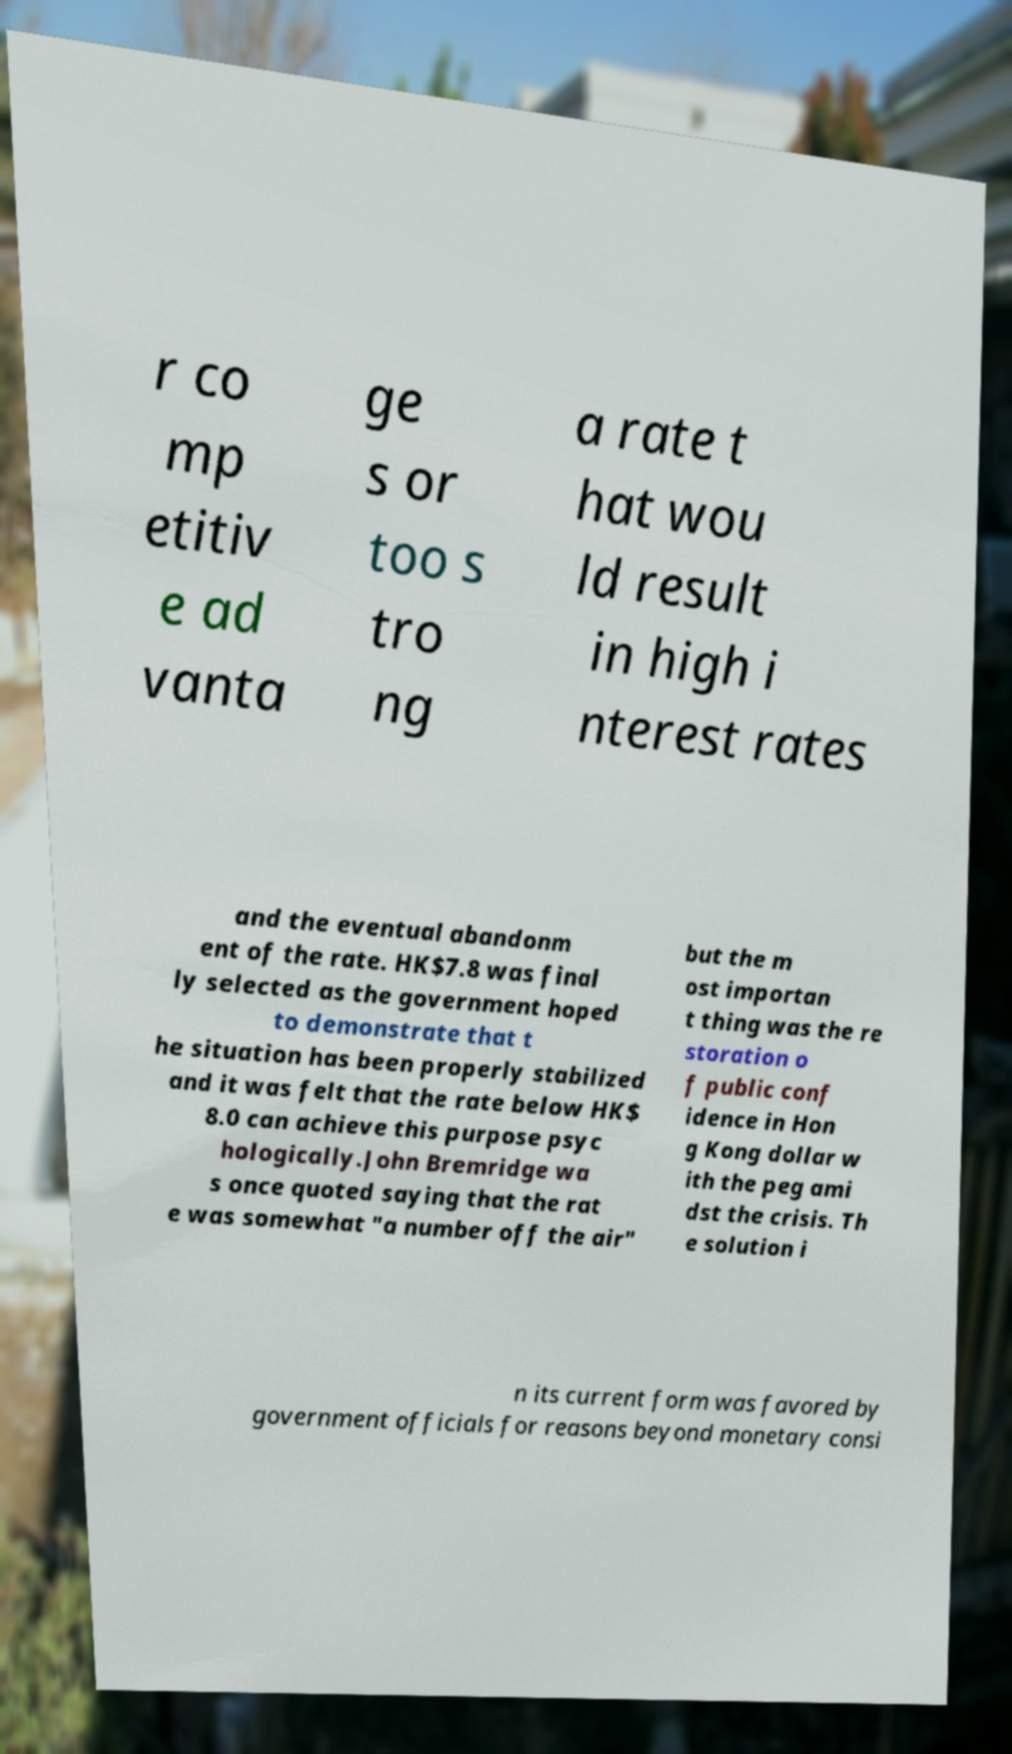There's text embedded in this image that I need extracted. Can you transcribe it verbatim? r co mp etitiv e ad vanta ge s or too s tro ng a rate t hat wou ld result in high i nterest rates and the eventual abandonm ent of the rate. HK$7.8 was final ly selected as the government hoped to demonstrate that t he situation has been properly stabilized and it was felt that the rate below HK$ 8.0 can achieve this purpose psyc hologically.John Bremridge wa s once quoted saying that the rat e was somewhat "a number off the air" but the m ost importan t thing was the re storation o f public conf idence in Hon g Kong dollar w ith the peg ami dst the crisis. Th e solution i n its current form was favored by government officials for reasons beyond monetary consi 